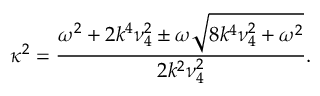Convert formula to latex. <formula><loc_0><loc_0><loc_500><loc_500>\kappa ^ { 2 } = \frac { \omega ^ { 2 } + 2 k ^ { 4 } \nu _ { 4 } ^ { 2 } \pm \omega \sqrt { 8 k ^ { 4 } \nu _ { 4 } ^ { 2 } + \omega ^ { 2 } } } { 2 k ^ { 2 } \nu _ { 4 } ^ { 2 } } .</formula> 